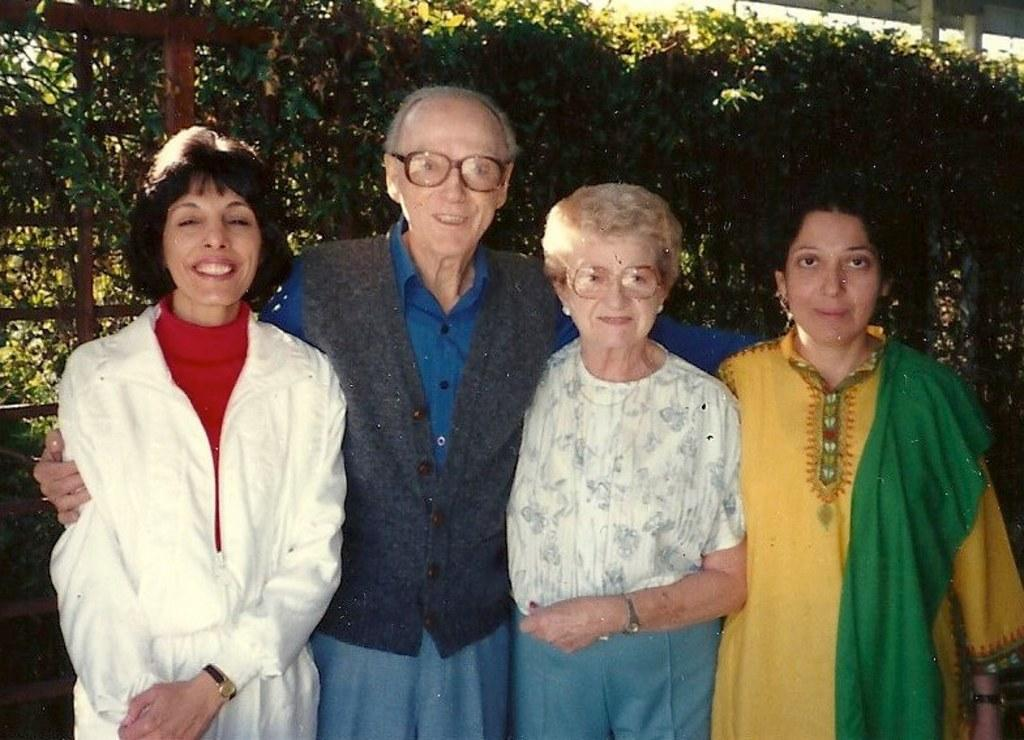What is present in the image? There are people in the image. What is the facial expression of the people in the image? The people are smiling. What can be seen in the background of the image? There are trees in the background of the image. How many trucks are visible in the image? There are no trucks present in the image. Is there a bear visible in the image? There is no bear present in the image. 